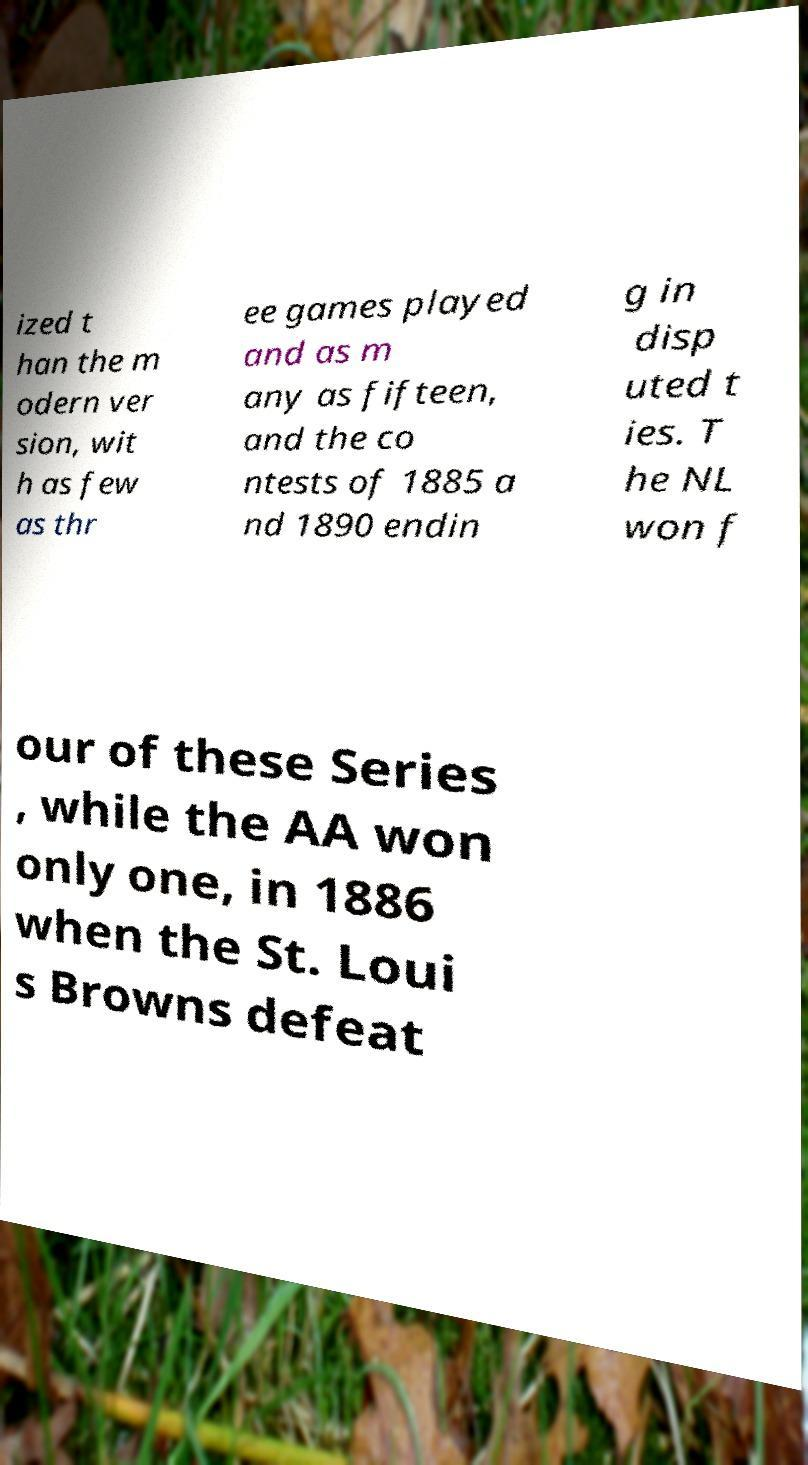Can you read and provide the text displayed in the image?This photo seems to have some interesting text. Can you extract and type it out for me? ized t han the m odern ver sion, wit h as few as thr ee games played and as m any as fifteen, and the co ntests of 1885 a nd 1890 endin g in disp uted t ies. T he NL won f our of these Series , while the AA won only one, in 1886 when the St. Loui s Browns defeat 